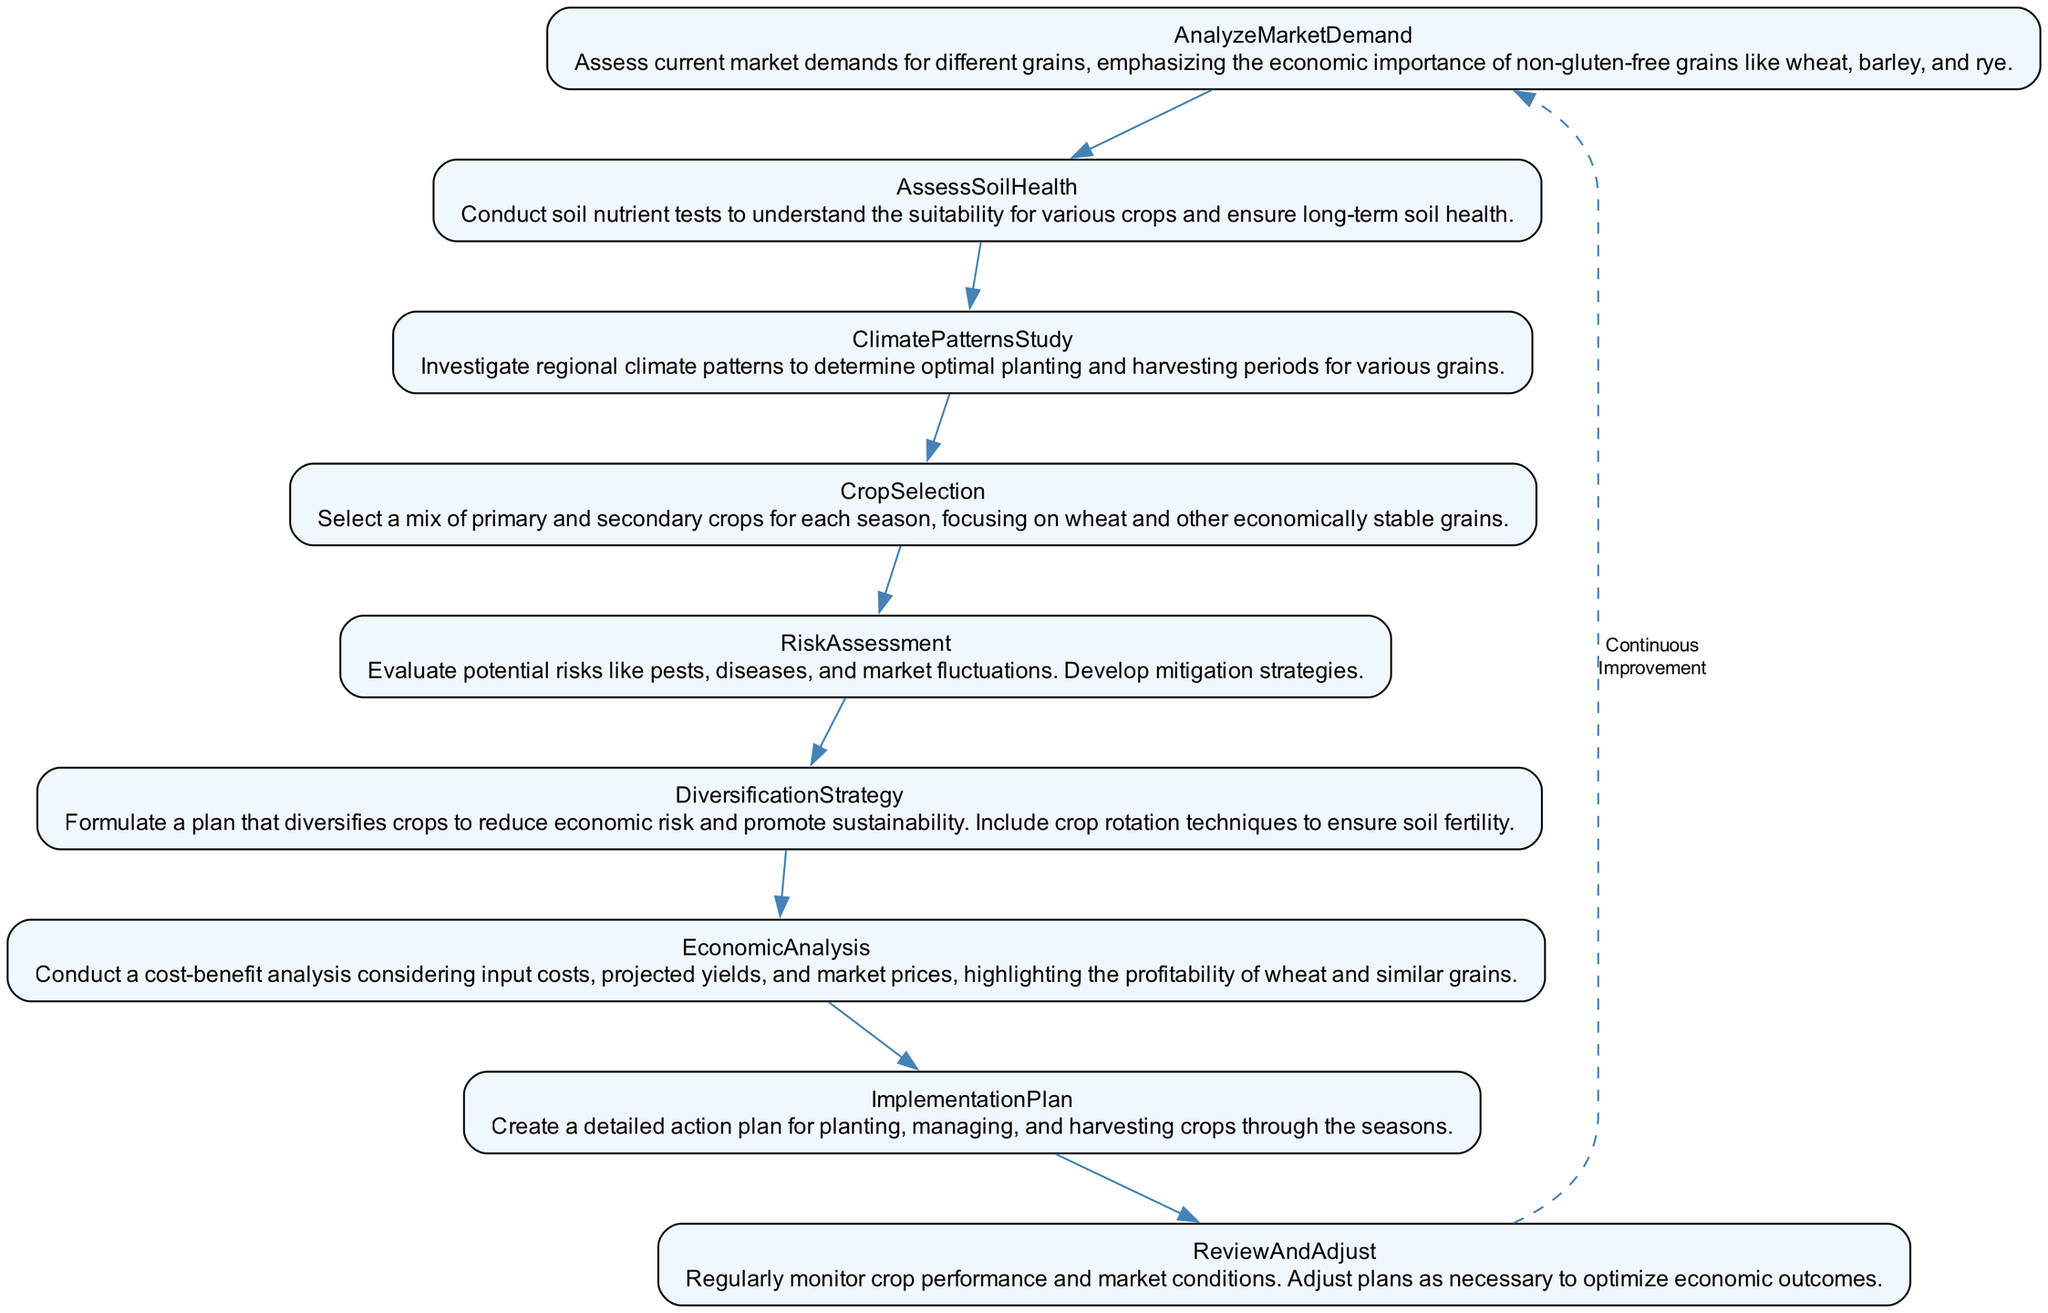What is the first element in the diagram? The first element in the diagram is "AnalyzeMarketDemand." This is based on the top-down flow of the diagram, where the first node listed is positioned at the topmost point.
Answer: AnalyzeMarketDemand How many elements are there in total? There are 9 elements in total as listed sequentially in the diagram. Each unique element is represented as a separate node.
Answer: 9 What is the relationship between "CropSelection" and "RiskAssessment"? "CropSelection" comes directly before "RiskAssessment" in the flowchart, indicating that selecting crops precedes the evaluation of risks related to those crops.
Answer: Directly next to each other Which element highlights the profitability of wheat and similar grains? The element that highlights the profitability of wheat and similar grains is "EconomicAnalysis." This node specifically focuses on conducting a cost-benefit analysis that emphasizes these grains.
Answer: EconomicAnalysis In what order do the elements follow after "ClimatePatternsStudy"? After "ClimatePatternsStudy," the next elements in order are "CropSelection," "RiskAssessment," "DiversificationStrategy," "EconomicAnalysis," "ImplementationPlan," and "ReviewAndAdjust." This shows the sequential process that follows the study of climate patterns.
Answer: CropSelection, RiskAssessment, DiversificationStrategy, EconomicAnalysis, ImplementationPlan, ReviewAndAdjust What does the "ReviewAndAdjust" node suggest regarding crop performance? The "ReviewAndAdjust" node suggests that there should be regular monitoring of crop performance and market conditions, highlighting the importance of adapting plans for optimal outcomes.
Answer: Regularly monitor and adjust plans Which strategy is formulated to reduce economic risk? The strategy formulated to reduce economic risk is "DiversificationStrategy," which emphasizes diversifying crops and including crop rotation techniques for sustainability.
Answer: DiversificationStrategy How does the diagram illustrate continuous improvement? The diagram illustrates continuous improvement through a dashed edge that connects "ReviewAndAdjust" back to "AnalyzeMarketDemand", indicating an ongoing cycle of improvement and responsiveness to changing conditions.
Answer: Dashed edge connecting back What is the primary focus of the "AssessSoilHealth" element? The primary focus of the "AssessSoilHealth" element is to conduct soil nutrient tests to gauge the suitability for various crops and maintain long-term soil health.
Answer: Conduct soil nutrient tests 